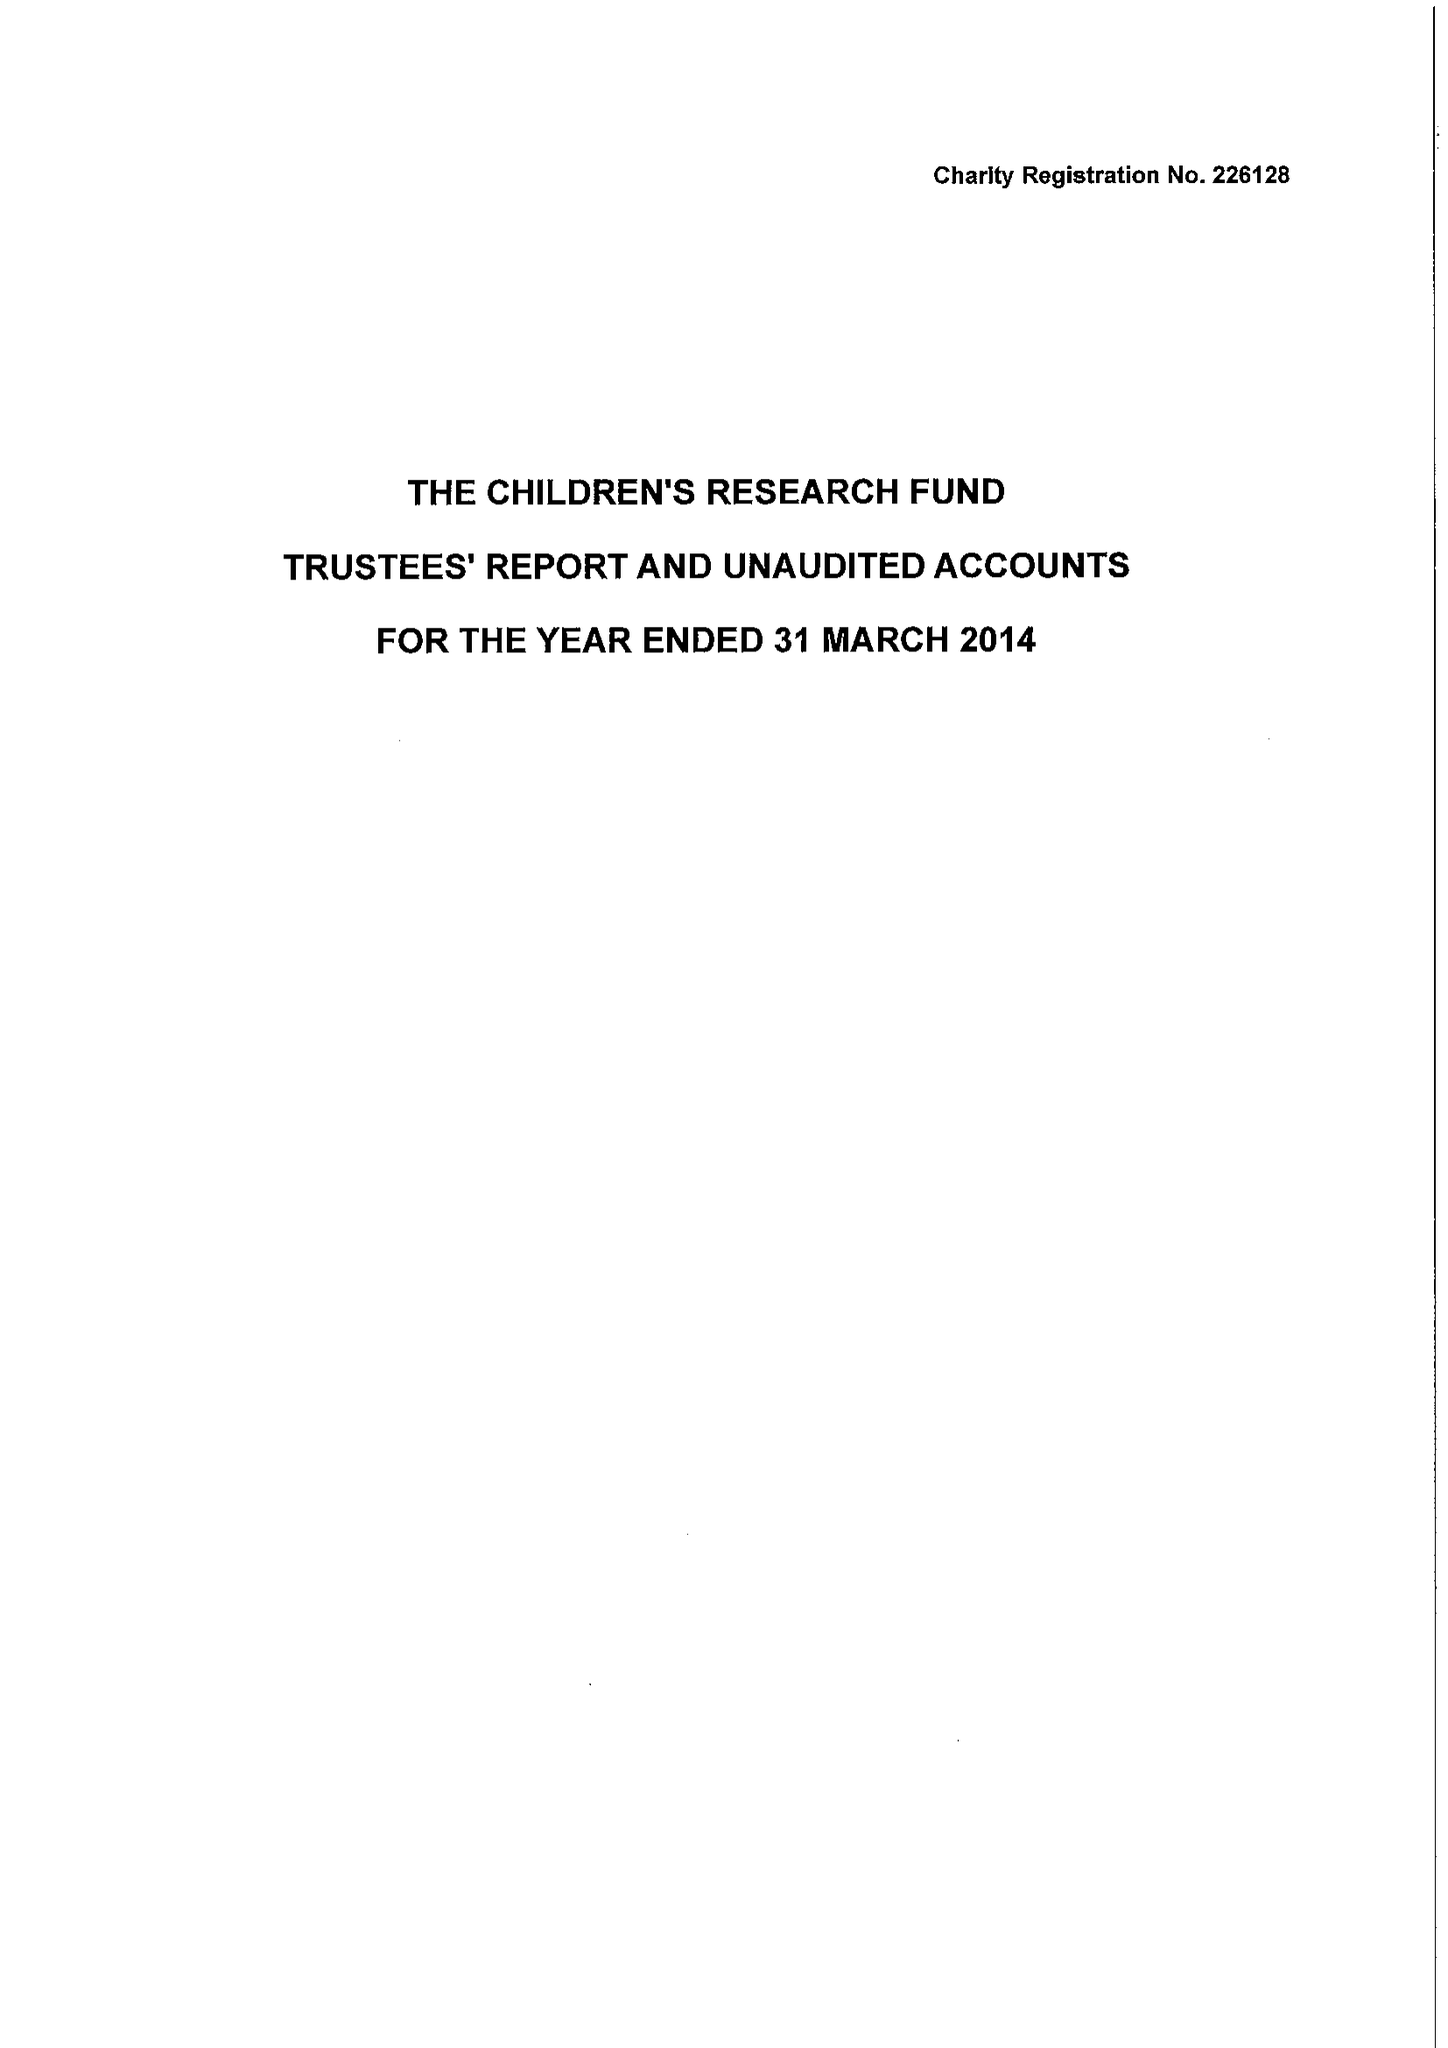What is the value for the charity_name?
Answer the question using a single word or phrase. The Children's Research Fund 